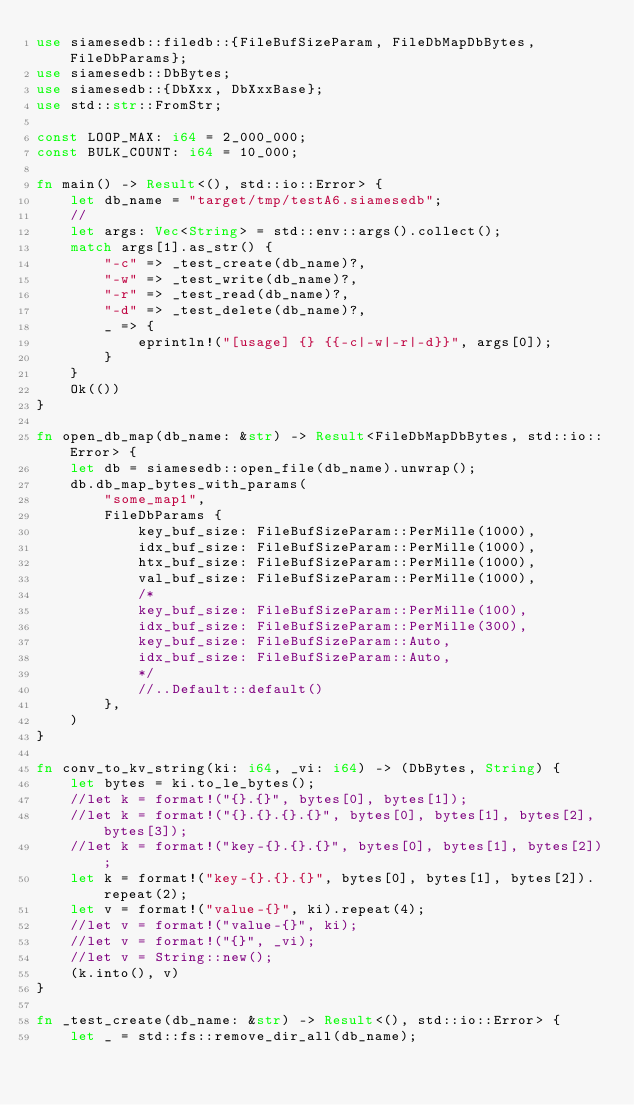Convert code to text. <code><loc_0><loc_0><loc_500><loc_500><_Rust_>use siamesedb::filedb::{FileBufSizeParam, FileDbMapDbBytes, FileDbParams};
use siamesedb::DbBytes;
use siamesedb::{DbXxx, DbXxxBase};
use std::str::FromStr;

const LOOP_MAX: i64 = 2_000_000;
const BULK_COUNT: i64 = 10_000;

fn main() -> Result<(), std::io::Error> {
    let db_name = "target/tmp/testA6.siamesedb";
    //
    let args: Vec<String> = std::env::args().collect();
    match args[1].as_str() {
        "-c" => _test_create(db_name)?,
        "-w" => _test_write(db_name)?,
        "-r" => _test_read(db_name)?,
        "-d" => _test_delete(db_name)?,
        _ => {
            eprintln!("[usage] {} {{-c|-w|-r|-d}}", args[0]);
        }
    }
    Ok(())
}

fn open_db_map(db_name: &str) -> Result<FileDbMapDbBytes, std::io::Error> {
    let db = siamesedb::open_file(db_name).unwrap();
    db.db_map_bytes_with_params(
        "some_map1",
        FileDbParams {
            key_buf_size: FileBufSizeParam::PerMille(1000),
            idx_buf_size: FileBufSizeParam::PerMille(1000),
            htx_buf_size: FileBufSizeParam::PerMille(1000),
            val_buf_size: FileBufSizeParam::PerMille(1000),
            /*
            key_buf_size: FileBufSizeParam::PerMille(100),
            idx_buf_size: FileBufSizeParam::PerMille(300),
            key_buf_size: FileBufSizeParam::Auto,
            idx_buf_size: FileBufSizeParam::Auto,
            */
            //..Default::default()
        },
    )
}

fn conv_to_kv_string(ki: i64, _vi: i64) -> (DbBytes, String) {
    let bytes = ki.to_le_bytes();
    //let k = format!("{}.{}", bytes[0], bytes[1]);
    //let k = format!("{}.{}.{}.{}", bytes[0], bytes[1], bytes[2], bytes[3]);
    //let k = format!("key-{}.{}.{}", bytes[0], bytes[1], bytes[2]);
    let k = format!("key-{}.{}.{}", bytes[0], bytes[1], bytes[2]).repeat(2);
    let v = format!("value-{}", ki).repeat(4);
    //let v = format!("value-{}", ki);
    //let v = format!("{}", _vi);
    //let v = String::new();
    (k.into(), v)
}

fn _test_create(db_name: &str) -> Result<(), std::io::Error> {
    let _ = std::fs::remove_dir_all(db_name);</code> 